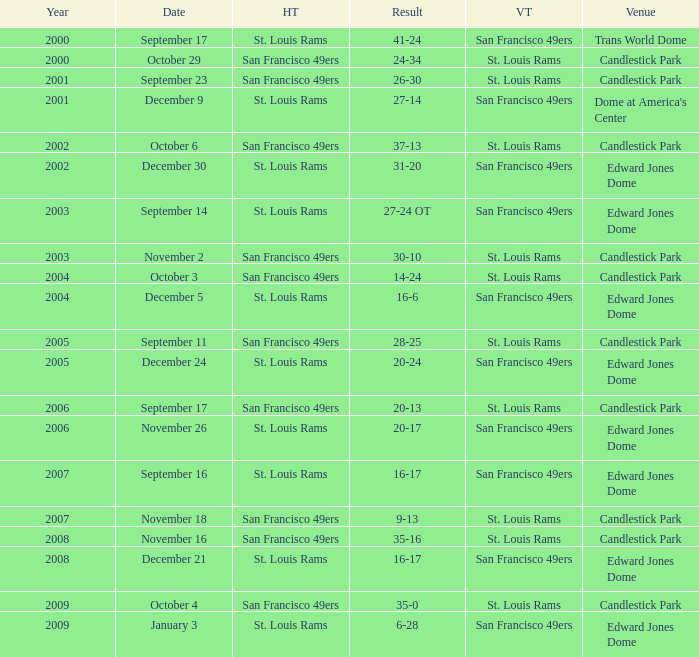What is the Result of the game on October 3? 14-24. 